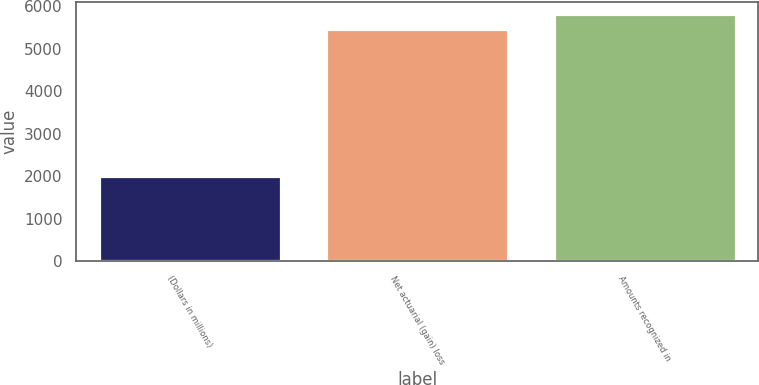Convert chart to OTSL. <chart><loc_0><loc_0><loc_500><loc_500><bar_chart><fcel>(Dollars in millions)<fcel>Net actuarial (gain) loss<fcel>Amounts recognized in<nl><fcel>2010<fcel>5461<fcel>5815.9<nl></chart> 